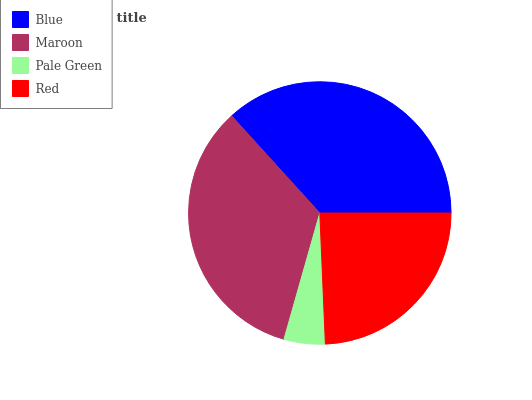Is Pale Green the minimum?
Answer yes or no. Yes. Is Blue the maximum?
Answer yes or no. Yes. Is Maroon the minimum?
Answer yes or no. No. Is Maroon the maximum?
Answer yes or no. No. Is Blue greater than Maroon?
Answer yes or no. Yes. Is Maroon less than Blue?
Answer yes or no. Yes. Is Maroon greater than Blue?
Answer yes or no. No. Is Blue less than Maroon?
Answer yes or no. No. Is Maroon the high median?
Answer yes or no. Yes. Is Red the low median?
Answer yes or no. Yes. Is Pale Green the high median?
Answer yes or no. No. Is Blue the low median?
Answer yes or no. No. 